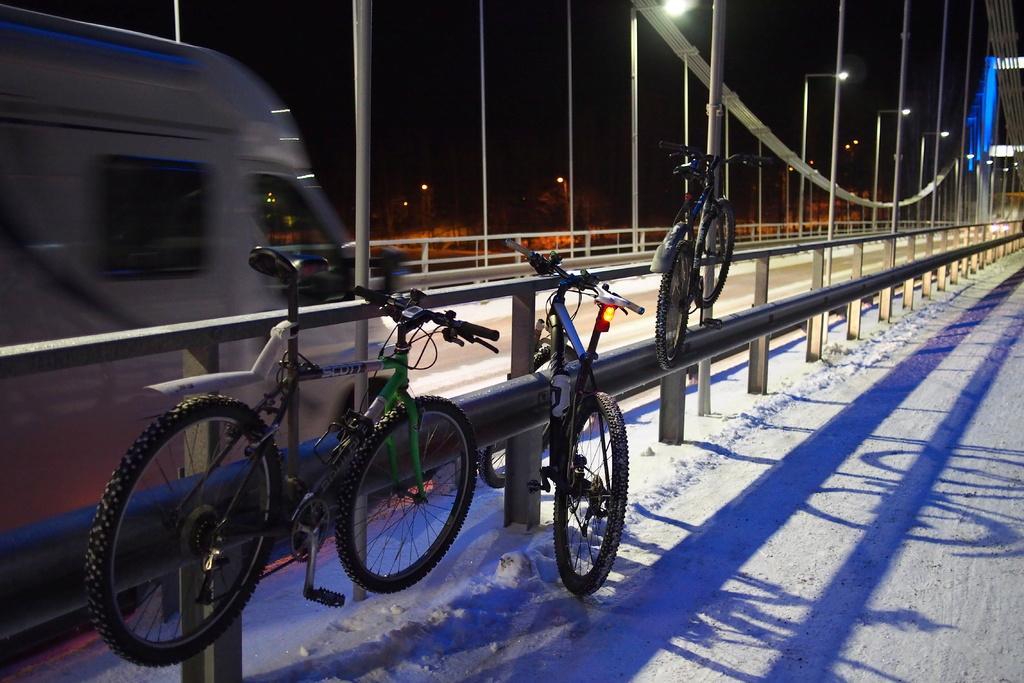How would you summarize this image in a sentence or two? In this image we can see a vehicle. We can see road, barriers and poles with lights. There are a few bicycles on the barriers. At the bottom we can see the snow. At the top the image is dark. 